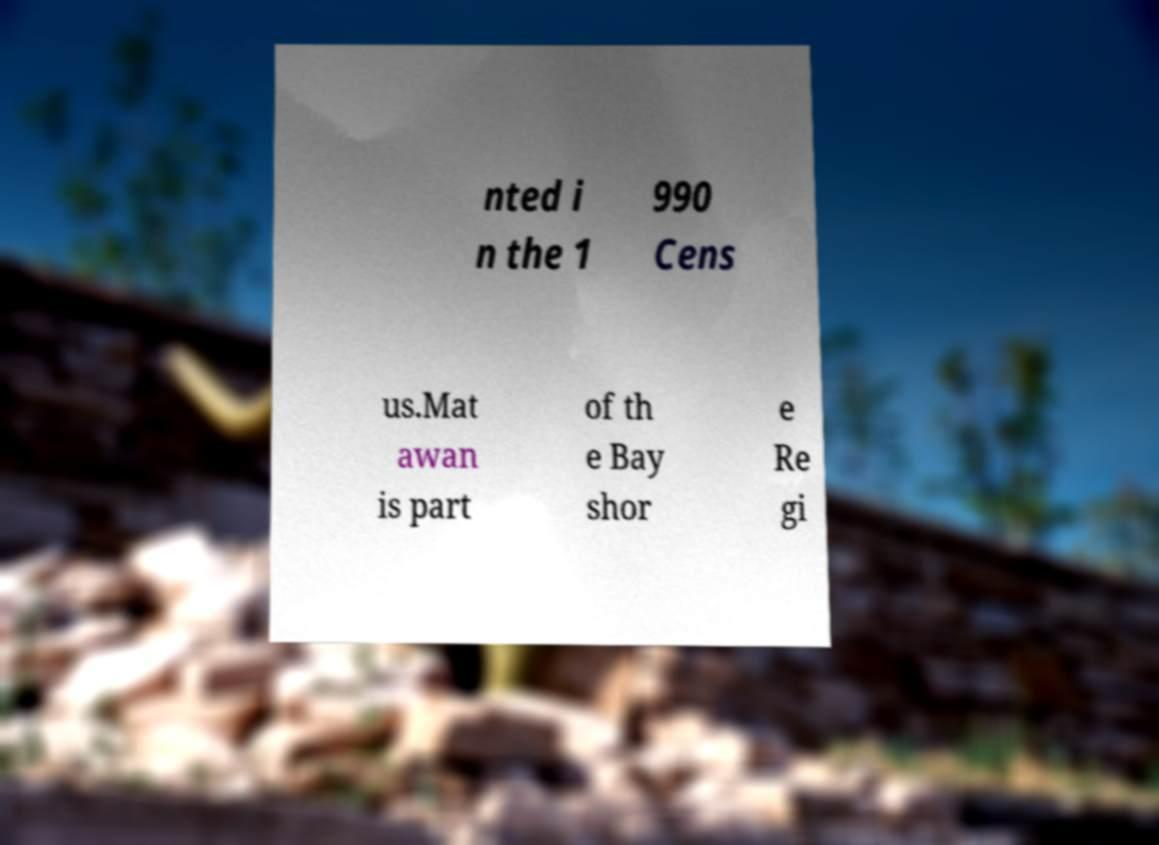Could you extract and type out the text from this image? nted i n the 1 990 Cens us.Mat awan is part of th e Bay shor e Re gi 